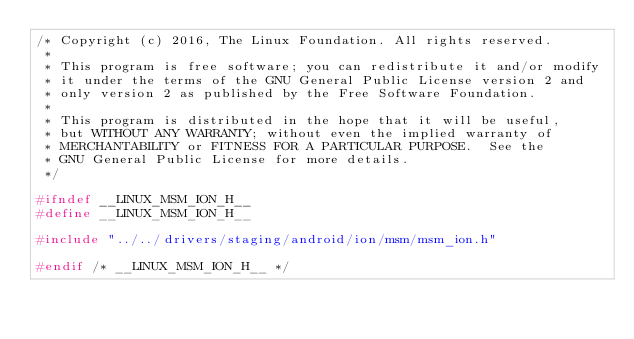Convert code to text. <code><loc_0><loc_0><loc_500><loc_500><_C_>/* Copyright (c) 2016, The Linux Foundation. All rights reserved.
 *
 * This program is free software; you can redistribute it and/or modify
 * it under the terms of the GNU General Public License version 2 and
 * only version 2 as published by the Free Software Foundation.
 *
 * This program is distributed in the hope that it will be useful,
 * but WITHOUT ANY WARRANTY; without even the implied warranty of
 * MERCHANTABILITY or FITNESS FOR A PARTICULAR PURPOSE.  See the
 * GNU General Public License for more details.
 */

#ifndef __LINUX_MSM_ION_H__
#define __LINUX_MSM_ION_H__

#include "../../drivers/staging/android/ion/msm/msm_ion.h"

#endif /* __LINUX_MSM_ION_H__ */
</code> 